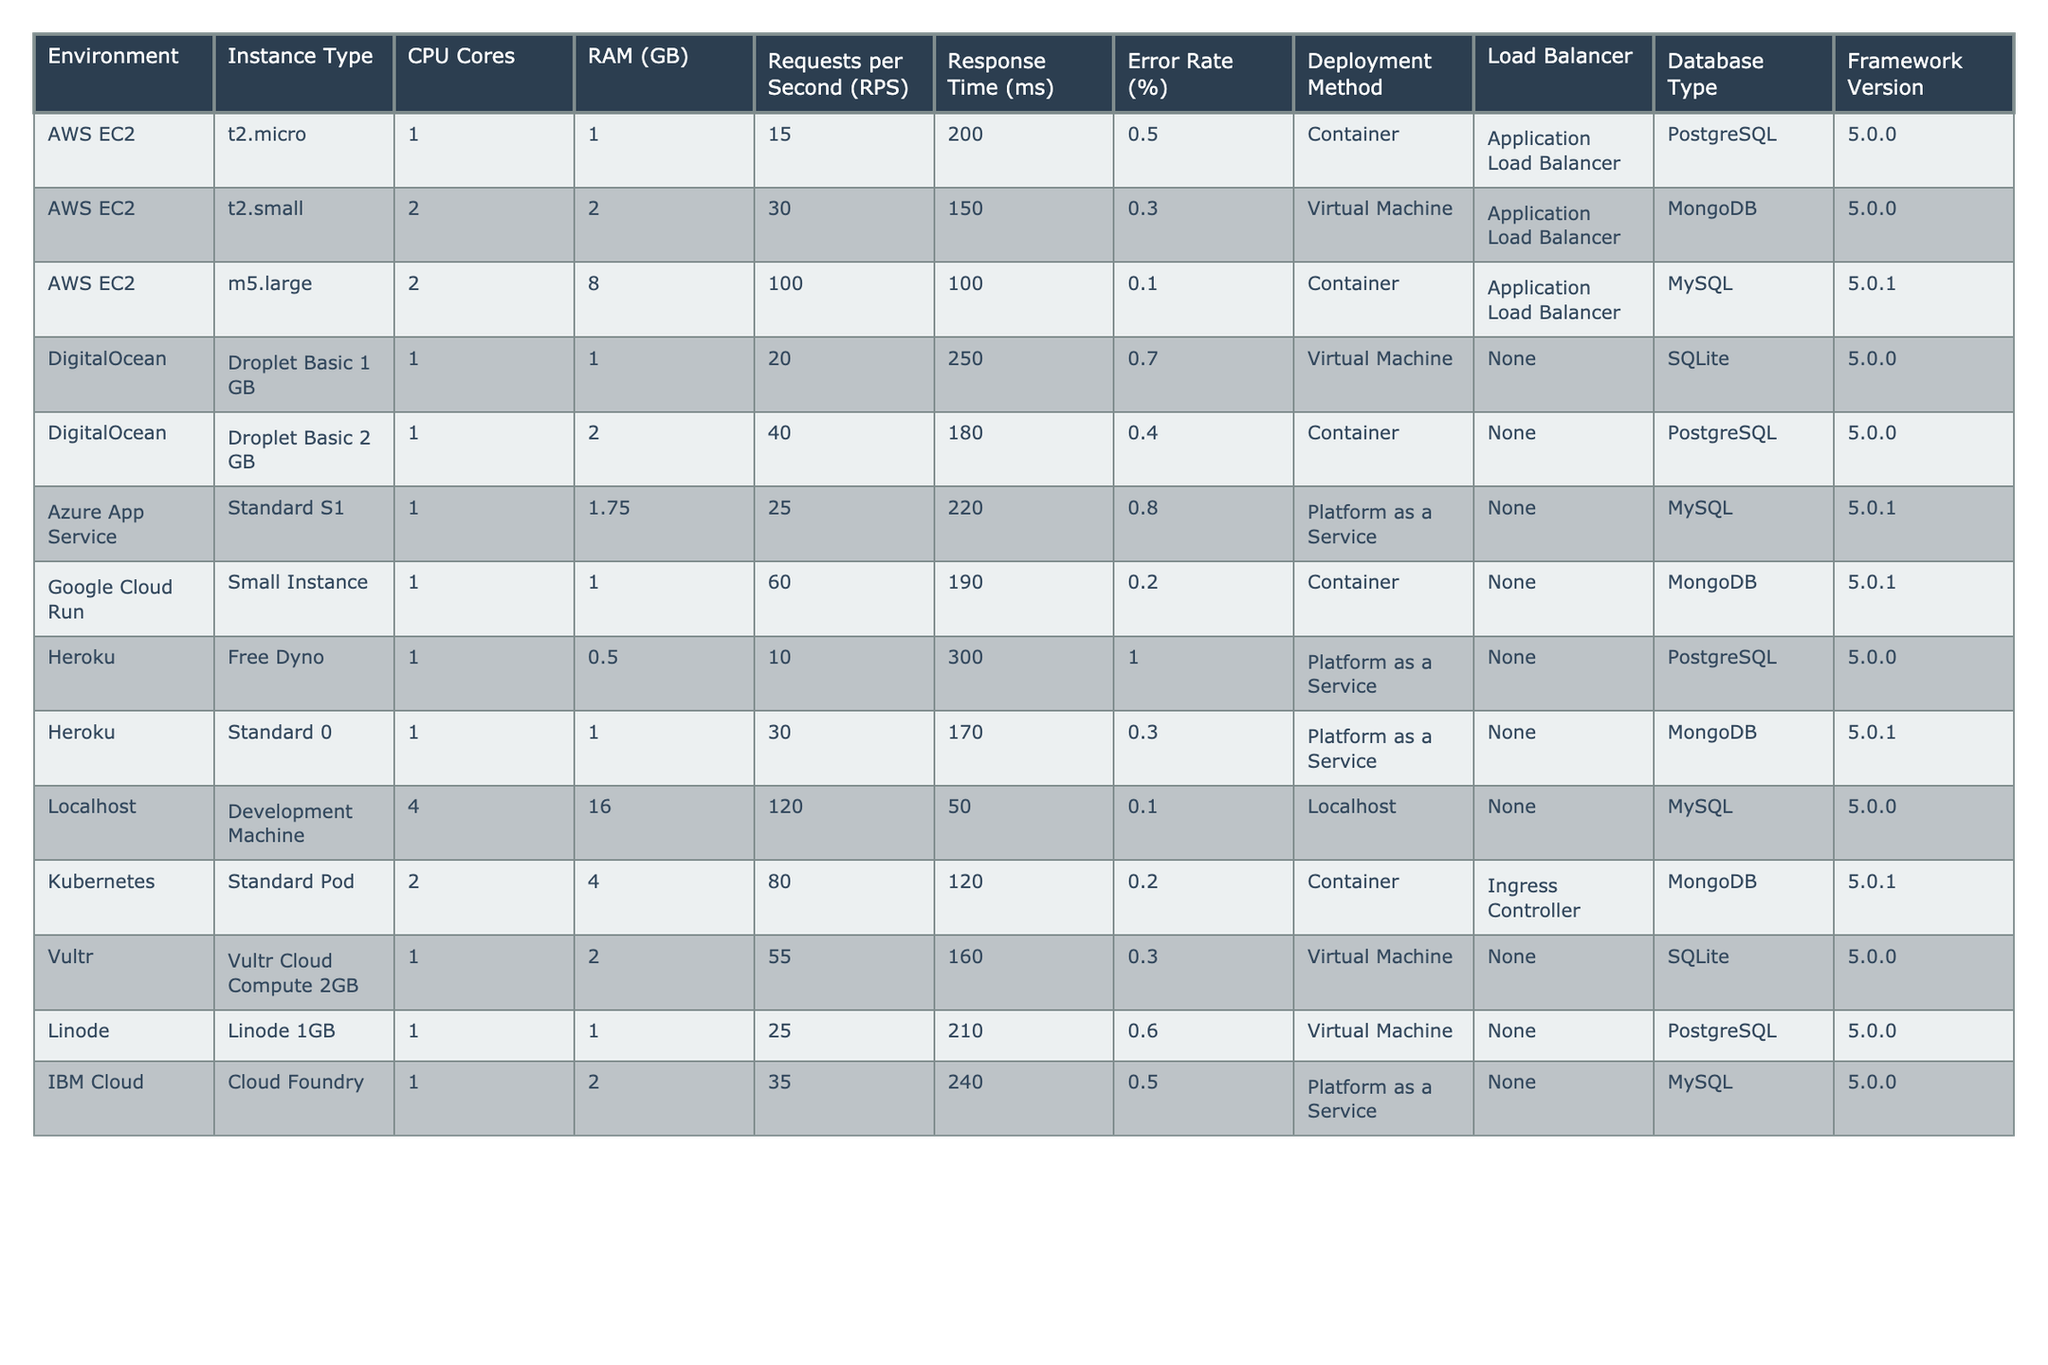What is the error rate for the m5.large instance in AWS EC2? The error rate for the m5.large instance is directly listed in the table under the 'Error Rate (%)' column. It shows 0.1%.
Answer: 0.1% Which environment has the highest Requests per Second (RPS)? By looking at the 'Requests per Second (RPS)' column, the highest value is 120 for the Development Machine in Localhost.
Answer: Localhost What is the average response time across all environments? First, I sum all the response times: (200 + 150 + 100 + 250 + 180 + 220 + 190 + 300 + 170 + 50 + 120 + 160 + 210 + 240) = 2,220 ms. There are 14 environments, so the average response time is 2,220 / 14 = 158.57 ms.
Answer: 158.57 ms Does the DigitalOcean environment using the "Droplet Basic 1 GB" have an error rate higher than 0.5%? Checking the error rate for the DigitalOcean "Droplet Basic 1 GB", it shows 0.7%, which is indeed higher than 0.5%.
Answer: Yes What is the difference in Requests per Second (RPS) between the AWS EC2 t2.small and the DigitalOcean Droplet Basic 2 GB? The RPS for t2.small is 30 and for Droplet Basic 2 GB is 40. The difference is 40 - 30 = 10 RPS.
Answer: 10 RPS Which deployment method shows the least response time and what is that time? Examining the 'Response Time (ms)' column, the least response time is 50 ms, which corresponds to the Localhost deployment method.
Answer: 50 ms How many environments use a Container as a deployment method, and what is the average Error Rate for these environments? The environments using Container are: m5.large in AWS EC2, Droplet Basic 2 GB in DigitalOcean, Google Cloud Run, Kubernetes, and Heroku Standard 0. This equals 5 environments. Their Error Rates are 0.1%, 0.4%, 0.2%, 0.2%, and 0.3%, which average to (0.1 + 0.4 + 0.2 + 0.2 + 0.3)/5 = 0.24%.
Answer: 0.24% Which instance type has the highest error rate, and what is that error rate? Scanning the 'Error Rate (%)' column, the highest value is 1.0% from the Heroku Free Dyno.
Answer: Heroku Free Dyno, 1.0% Compare the RPS of the Standard S1 in Azure App Service with the Standard 0 in Heroku. Which one has a better RPS and by what amount? The RPS for Standard S1 in Azure App Service is 25 and for Standard 0 in Heroku is 30. Comparing these, Heroku is better by 30 - 25 = 5 RPS.
Answer: 5 RPS What is the type of database used for the Standard Pod in Kubernetes deployment? Referring to the "Database Type" column, the Standard Pod in Kubernetes uses MongoDB as the database type.
Answer: MongoDB 